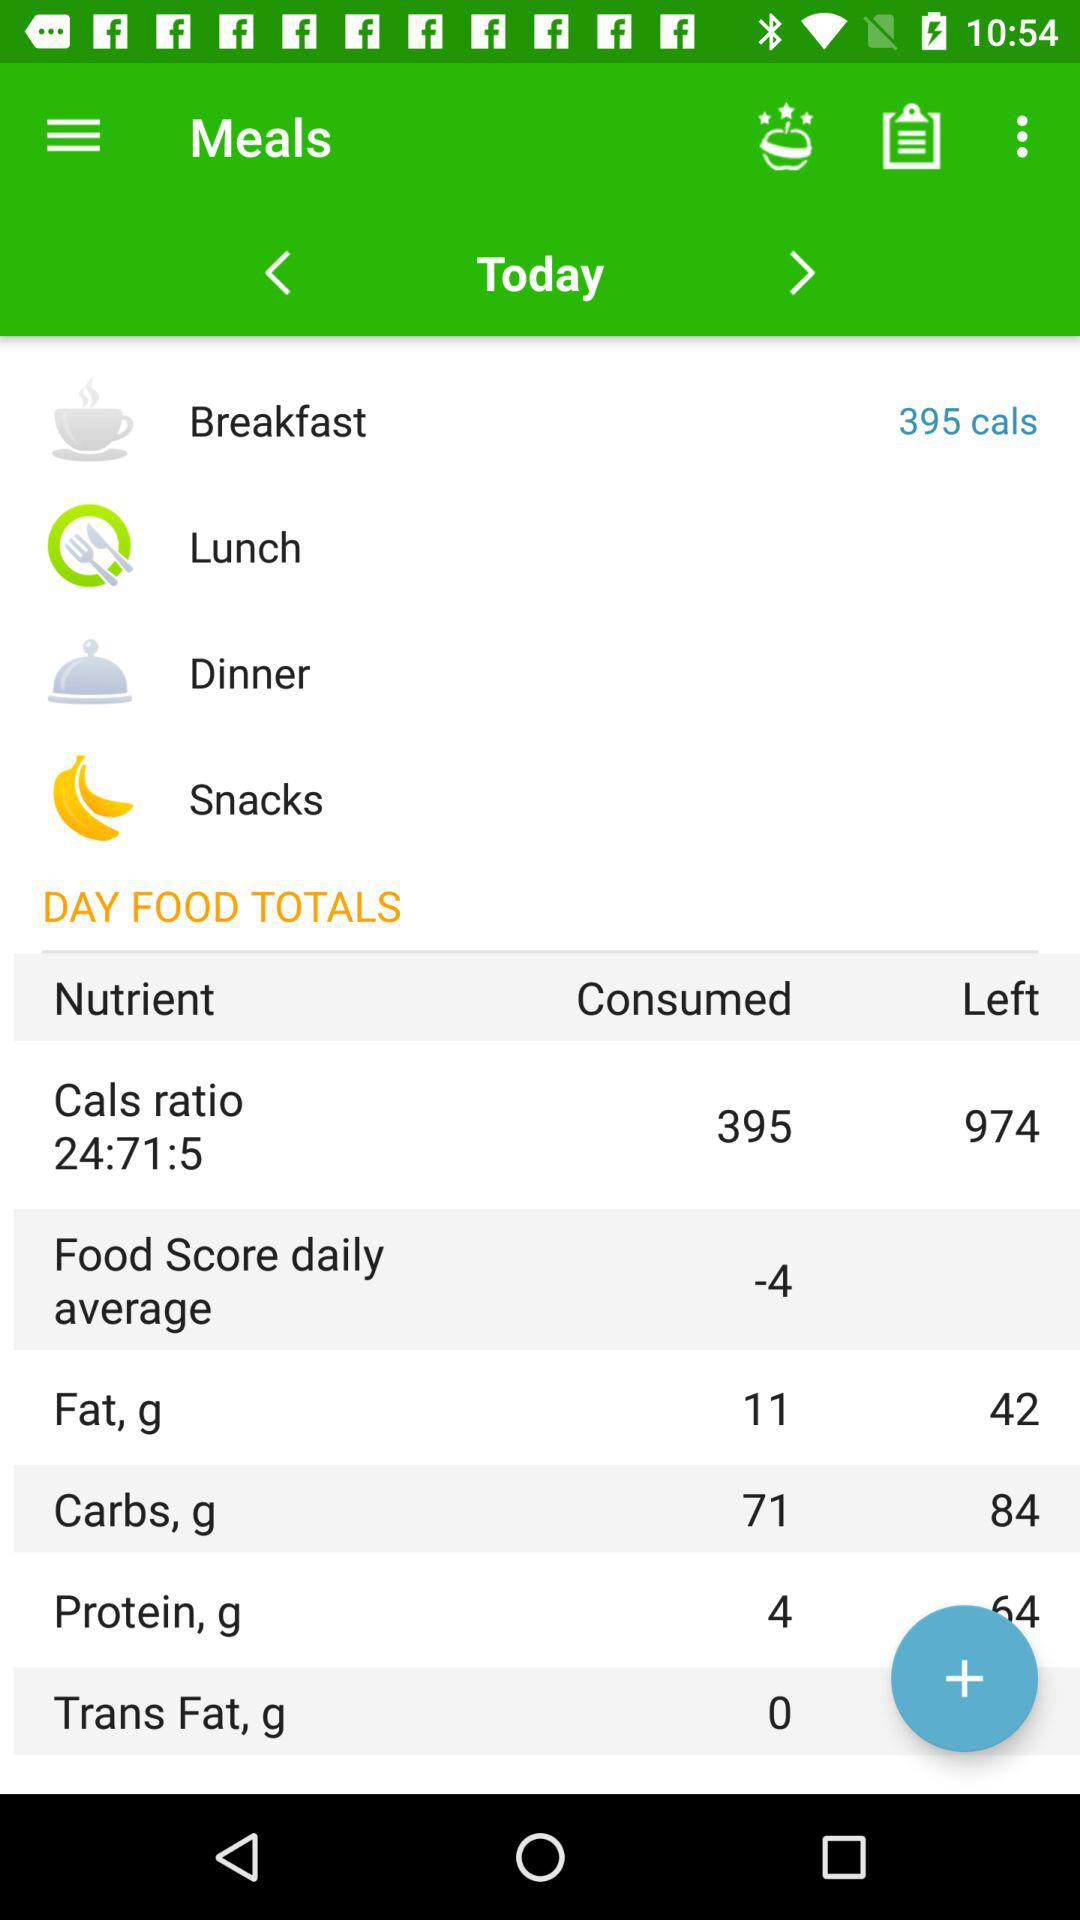What is the calorie count for breakfast? The calorie count is 395. 